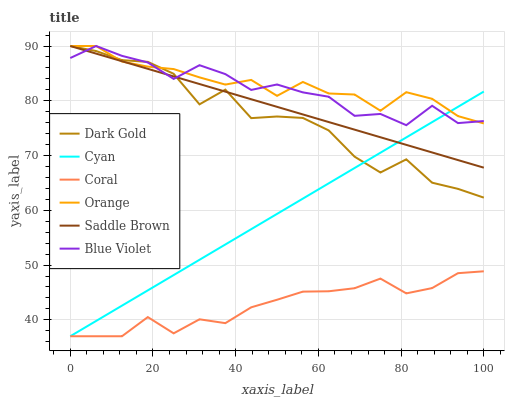Does Coral have the minimum area under the curve?
Answer yes or no. Yes. Does Orange have the maximum area under the curve?
Answer yes or no. Yes. Does Orange have the minimum area under the curve?
Answer yes or no. No. Does Coral have the maximum area under the curve?
Answer yes or no. No. Is Cyan the smoothest?
Answer yes or no. Yes. Is Dark Gold the roughest?
Answer yes or no. Yes. Is Coral the smoothest?
Answer yes or no. No. Is Coral the roughest?
Answer yes or no. No. Does Coral have the lowest value?
Answer yes or no. Yes. Does Orange have the lowest value?
Answer yes or no. No. Does Blue Violet have the highest value?
Answer yes or no. Yes. Does Coral have the highest value?
Answer yes or no. No. Is Coral less than Saddle Brown?
Answer yes or no. Yes. Is Saddle Brown greater than Coral?
Answer yes or no. Yes. Does Dark Gold intersect Blue Violet?
Answer yes or no. Yes. Is Dark Gold less than Blue Violet?
Answer yes or no. No. Is Dark Gold greater than Blue Violet?
Answer yes or no. No. Does Coral intersect Saddle Brown?
Answer yes or no. No. 